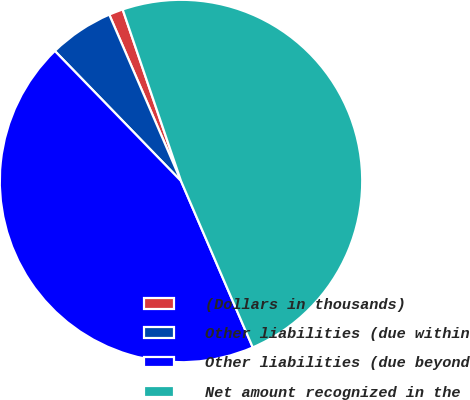Convert chart. <chart><loc_0><loc_0><loc_500><loc_500><pie_chart><fcel>(Dollars in thousands)<fcel>Other liabilities (due within<fcel>Other liabilities (due beyond<fcel>Net amount recognized in the<nl><fcel>1.26%<fcel>5.78%<fcel>44.22%<fcel>48.74%<nl></chart> 